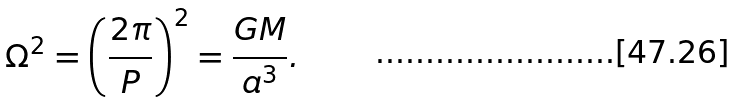<formula> <loc_0><loc_0><loc_500><loc_500>\Omega ^ { 2 } = \left ( \frac { 2 \pi } { P } \right ) ^ { 2 } = \frac { G M } { a ^ { 3 } } .</formula> 